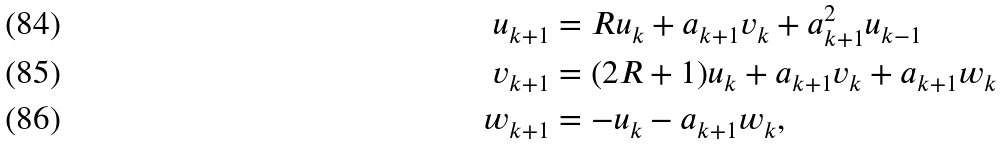Convert formula to latex. <formula><loc_0><loc_0><loc_500><loc_500>u _ { k + 1 } & = R u _ { k } + a _ { k + 1 } v _ { k } + a _ { k + 1 } ^ { 2 } u _ { k - 1 } \\ v _ { k + 1 } & = ( 2 R + 1 ) u _ { k } + a _ { k + 1 } v _ { k } + a _ { k + 1 } w _ { k } \\ w _ { k + 1 } & = - u _ { k } - a _ { k + 1 } w _ { k } ,</formula> 